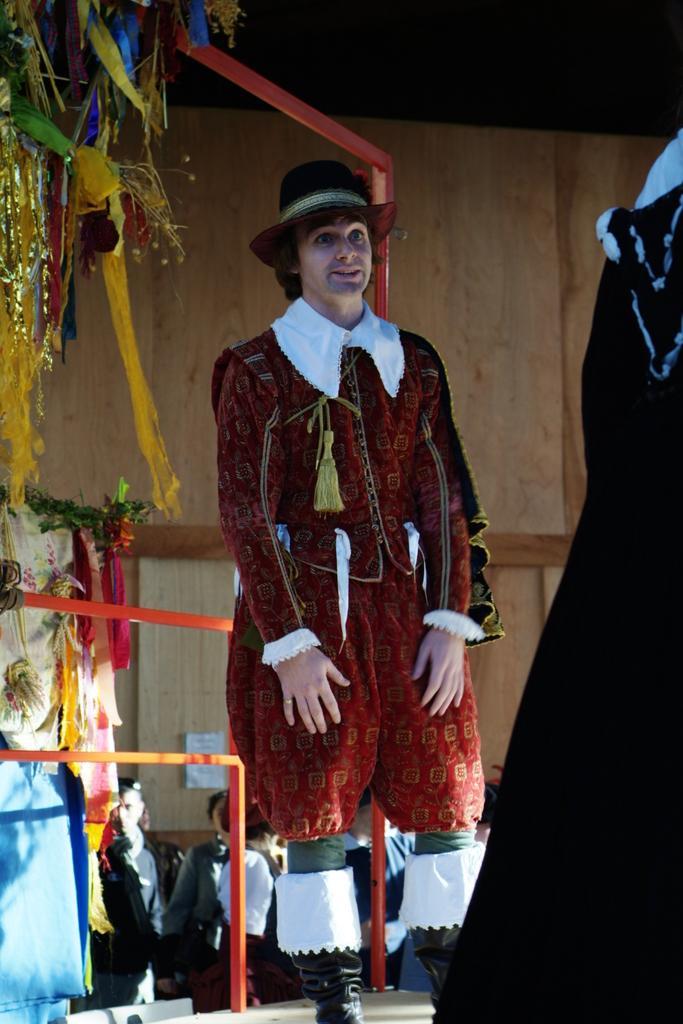Can you describe this image briefly? In the center of the image, we can see a person wearing costume and wearing a hat. In the background, there are streamers, rods, clothes and we can see some other people and on the right, there is a person standing and we can see a board. At the bottom, there is floor. 